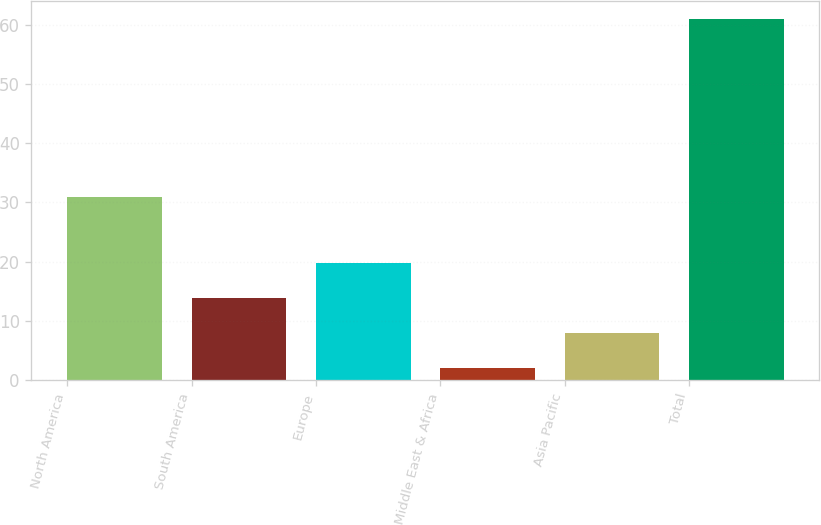Convert chart. <chart><loc_0><loc_0><loc_500><loc_500><bar_chart><fcel>North America<fcel>South America<fcel>Europe<fcel>Middle East & Africa<fcel>Asia Pacific<fcel>Total<nl><fcel>31<fcel>13.8<fcel>19.7<fcel>2<fcel>7.9<fcel>61<nl></chart> 